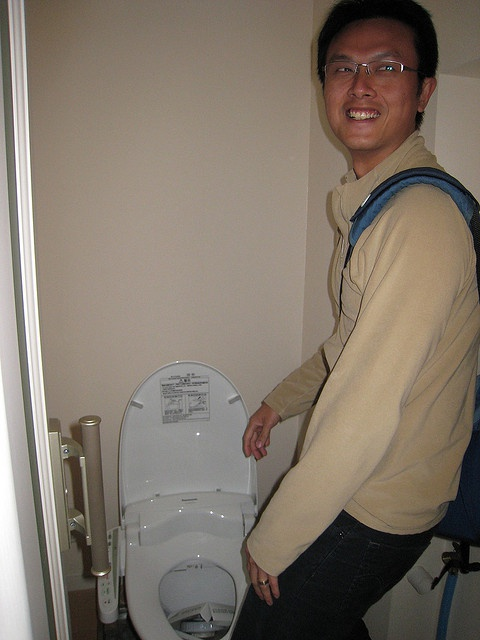Describe the objects in this image and their specific colors. I can see people in black, tan, and gray tones, toilet in black and gray tones, and backpack in black, gray, blue, and darkblue tones in this image. 